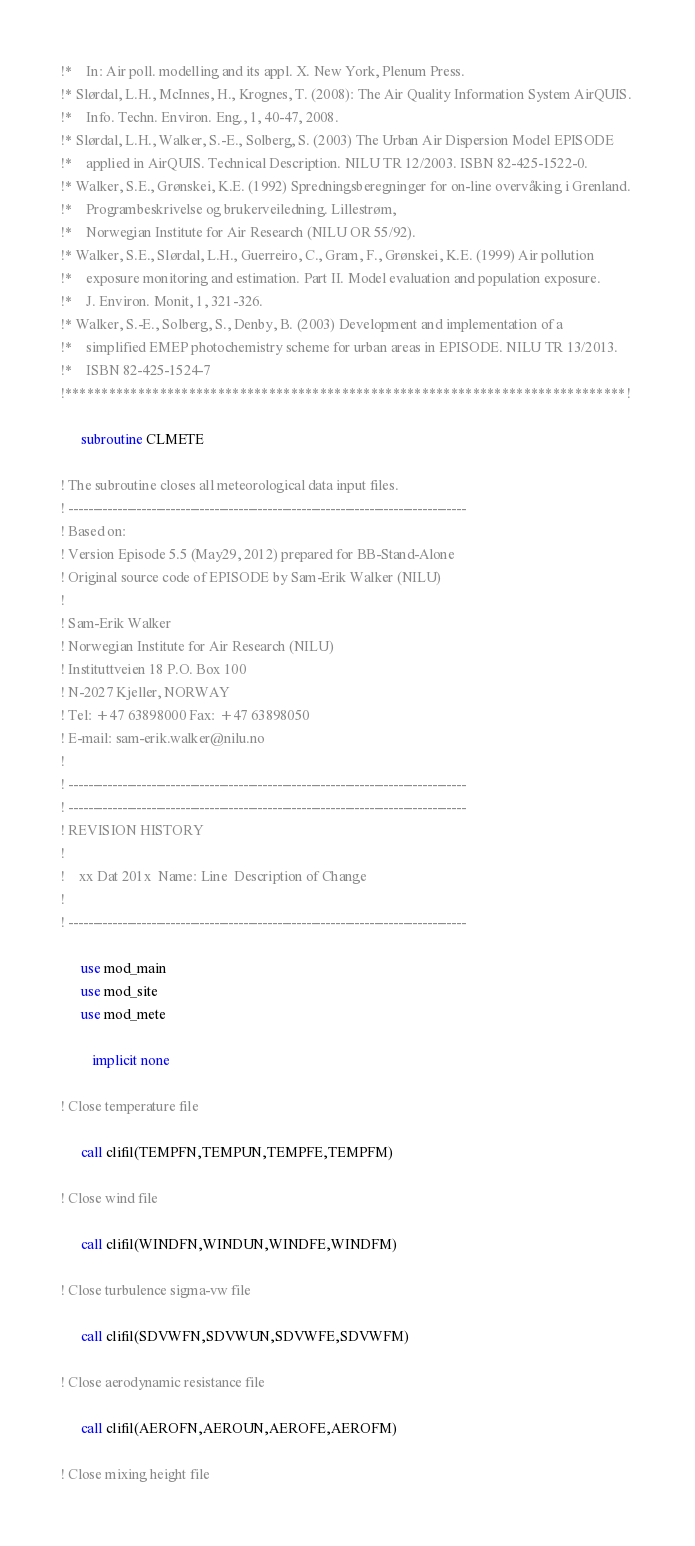Convert code to text. <code><loc_0><loc_0><loc_500><loc_500><_FORTRAN_>!*    In: Air poll. modelling and its appl. X. New York, Plenum Press.
!* Slørdal, L.H., McInnes, H., Krognes, T. (2008): The Air Quality Information System AirQUIS. 
!*    Info. Techn. Environ. Eng., 1, 40-47, 2008.
!* Slørdal, L.H., Walker, S.-E., Solberg, S. (2003) The Urban Air Dispersion Model EPISODE 
!*    applied in AirQUIS. Technical Description. NILU TR 12/2003. ISBN 82-425-1522-0.
!* Walker, S.E., Grønskei, K.E. (1992) Spredningsberegninger for on-line overvåking i Grenland. 
!*    Programbeskrivelse og brukerveiledning. Lillestrøm, 
!*    Norwegian Institute for Air Research (NILU OR 55/92).
!* Walker, S.E., Slørdal, L.H., Guerreiro, C., Gram, F., Grønskei, K.E. (1999) Air pollution 
!*    exposure monitoring and estimation. Part II. Model evaluation and population exposure. 
!*    J. Environ. Monit, 1, 321-326.
!* Walker, S.-E., Solberg, S., Denby, B. (2003) Development and implementation of a 
!*    simplified EMEP photochemistry scheme for urban areas in EPISODE. NILU TR 13/2013. 
!*    ISBN 82-425-1524-7
!*****************************************************************************! 

      subroutine CLMETE

! The subroutine closes all meteorological data input files.
! ----------------------------------------------------------------------------------
! Based on:
! Version Episode 5.5 (May29, 2012) prepared for BB-Stand-Alone
! Original source code of EPISODE by Sam-Erik Walker (NILU)
!
! Sam-Erik Walker
! Norwegian Institute for Air Research (NILU)
! Instituttveien 18 P.O. Box 100
! N-2027 Kjeller, NORWAY
! Tel: +47 63898000 Fax: +47 63898050
! E-mail: sam-erik.walker@nilu.no
!
! ----------------------------------------------------------------------------------
! ----------------------------------------------------------------------------------
! REVISION HISTORY
!
!    xx Dat 201x  Name: Line  Description of Change
!
! ----------------------------------------------------------------------------------

      use mod_main
      use mod_site
      use mod_mete

         implicit none

! Close temperature file

      call clifil(TEMPFN,TEMPUN,TEMPFE,TEMPFM)

! Close wind file

      call clifil(WINDFN,WINDUN,WINDFE,WINDFM)

! Close turbulence sigma-vw file

      call clifil(SDVWFN,SDVWUN,SDVWFE,SDVWFM)

! Close aerodynamic resistance file

      call clifil(AEROFN,AEROUN,AEROFE,AEROFM)

! Close mixing height file
</code> 